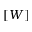<formula> <loc_0><loc_0><loc_500><loc_500>[ W ]</formula> 